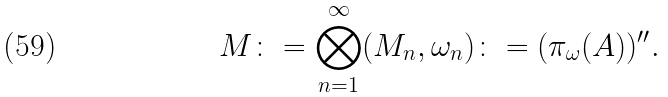Convert formula to latex. <formula><loc_0><loc_0><loc_500><loc_500>M \colon = \bigotimes _ { n = 1 } ^ { \infty } ( M _ { n } , \omega _ { n } ) \colon = ( \pi _ { \omega } ( A ) ) ^ { \prime \prime } .</formula> 